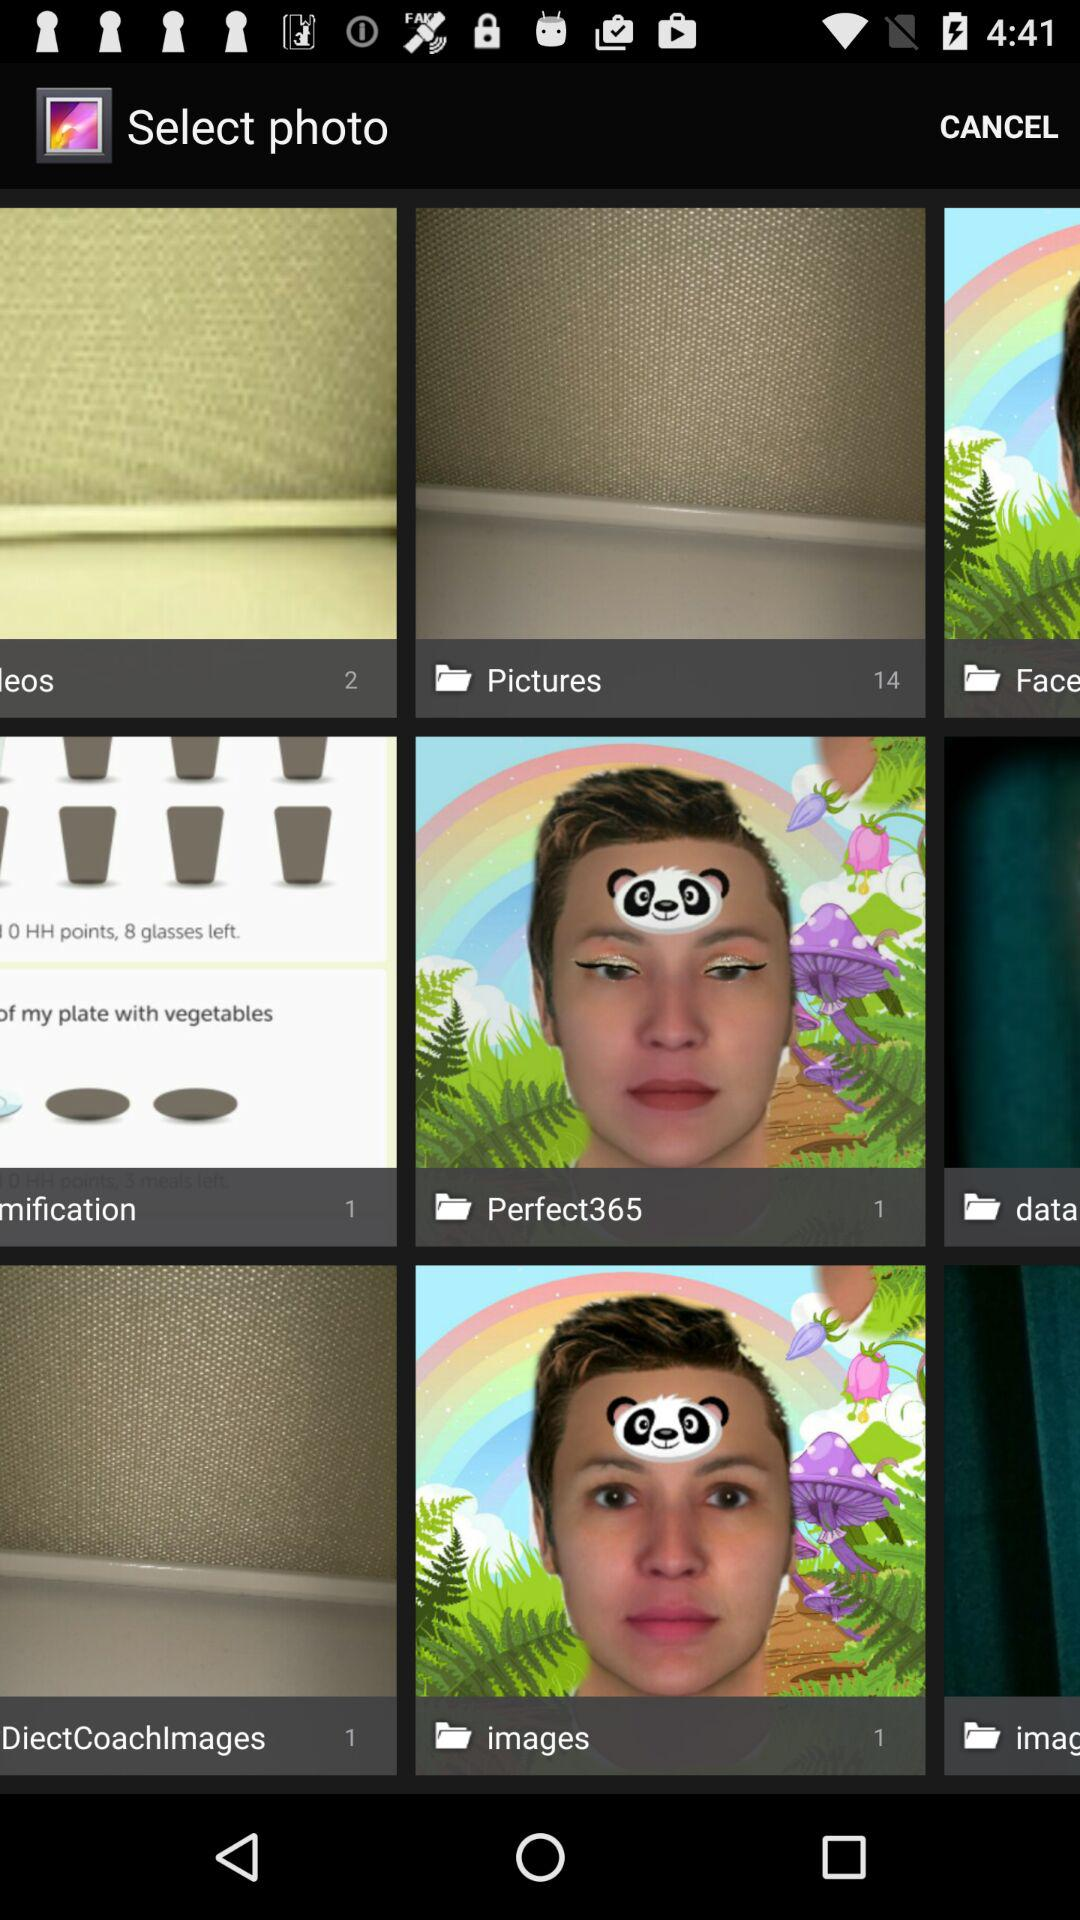How many images are in the "Pictures" folder? There are 14 images. 